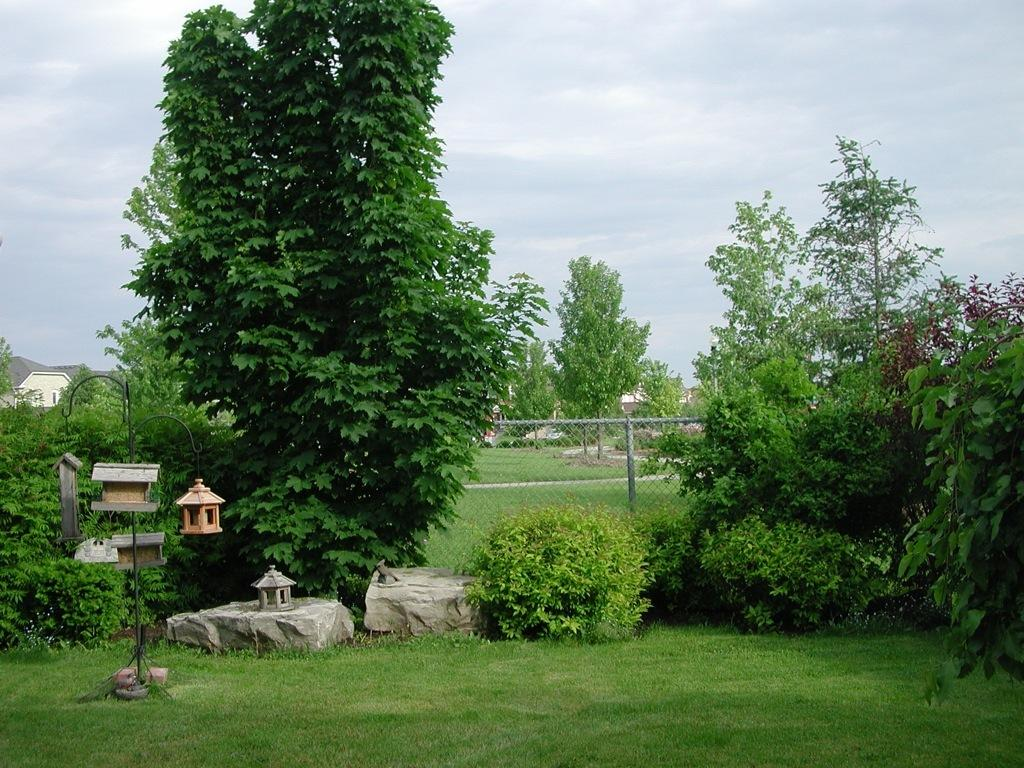What type of vegetation is on the left side of the image? There are green trees on the left side of the image. What is located in the middle of the image? There is an iron net in the middle of the image. What is visible at the top of the image? The sky is visible at the top of the image. Can you tell me how the maid is cleaning the bath in the image? There is no maid or bath present in the image. What type of flight is visible in the image? There is no flight present in the image. 